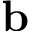<formula> <loc_0><loc_0><loc_500><loc_500>b</formula> 